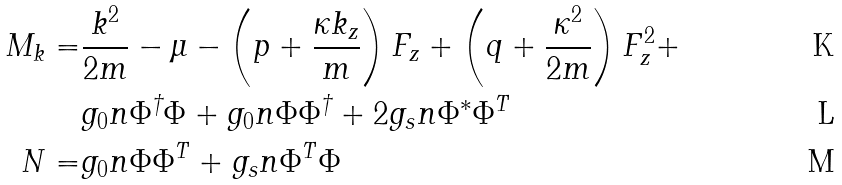Convert formula to latex. <formula><loc_0><loc_0><loc_500><loc_500>M _ { k } = & \frac { k ^ { 2 } } { 2 m } - \mu - \left ( p + \frac { \kappa k _ { z } } { m } \right ) F _ { z } + \left ( q + \frac { \kappa ^ { 2 } } { 2 m } \right ) F _ { z } ^ { 2 } + \\ & g _ { 0 } n \Phi ^ { \dagger } \Phi + g _ { 0 } n \Phi \Phi ^ { \dagger } + 2 g _ { s } n \Phi ^ { * } \Phi ^ { T } \\ N = & g _ { 0 } n \Phi \Phi ^ { T } + g _ { s } n \Phi ^ { T } \Phi</formula> 